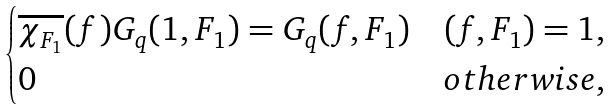<formula> <loc_0><loc_0><loc_500><loc_500>\begin{cases} \overline { \chi _ { F _ { 1 } } } ( f ) G _ { q } ( 1 , F _ { 1 } ) = G _ { q } ( f , F _ { 1 } ) & ( f , F _ { 1 } ) = 1 , \\ 0 & o t h e r w i s e , \end{cases}</formula> 